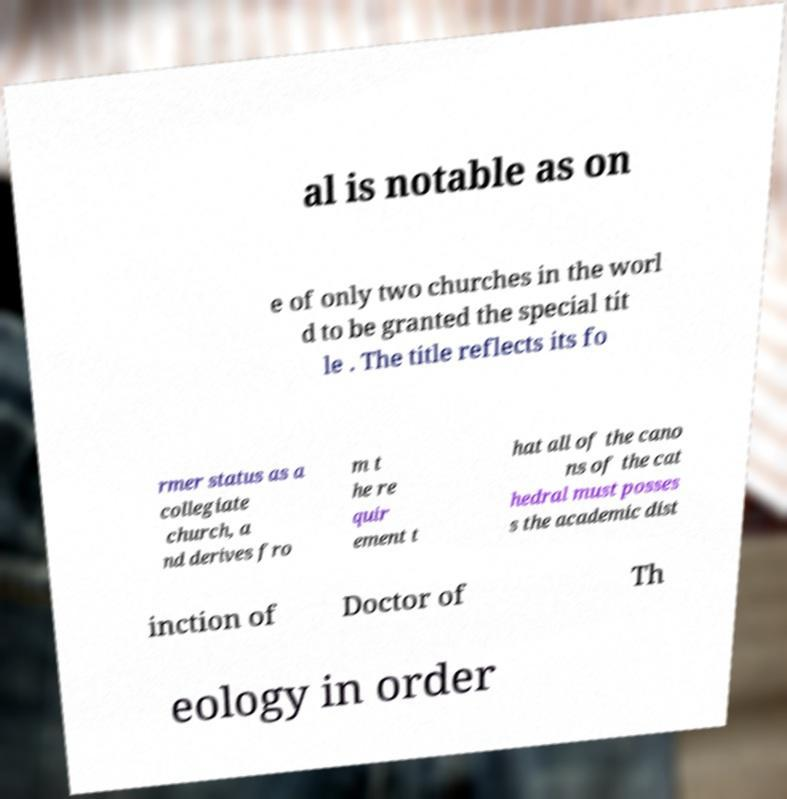Can you read and provide the text displayed in the image?This photo seems to have some interesting text. Can you extract and type it out for me? al is notable as on e of only two churches in the worl d to be granted the special tit le . The title reflects its fo rmer status as a collegiate church, a nd derives fro m t he re quir ement t hat all of the cano ns of the cat hedral must posses s the academic dist inction of Doctor of Th eology in order 